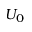Convert formula to latex. <formula><loc_0><loc_0><loc_500><loc_500>U _ { 0 }</formula> 